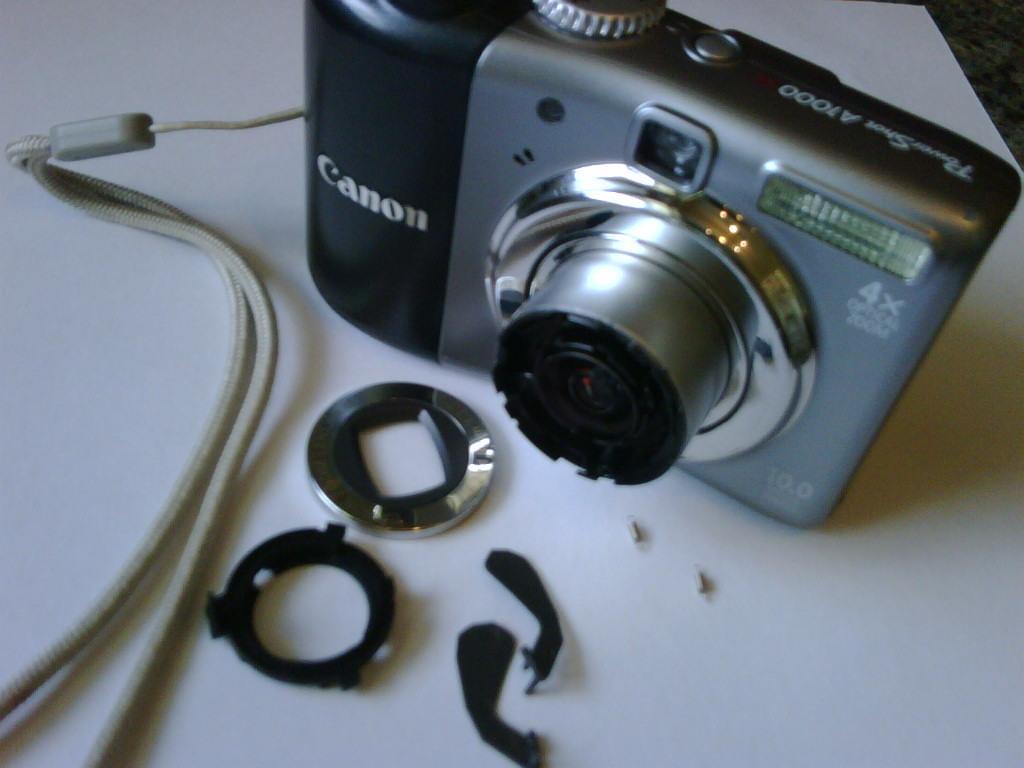In one or two sentences, can you explain what this image depicts? In this image, we can see a camera kept on the white color object. 